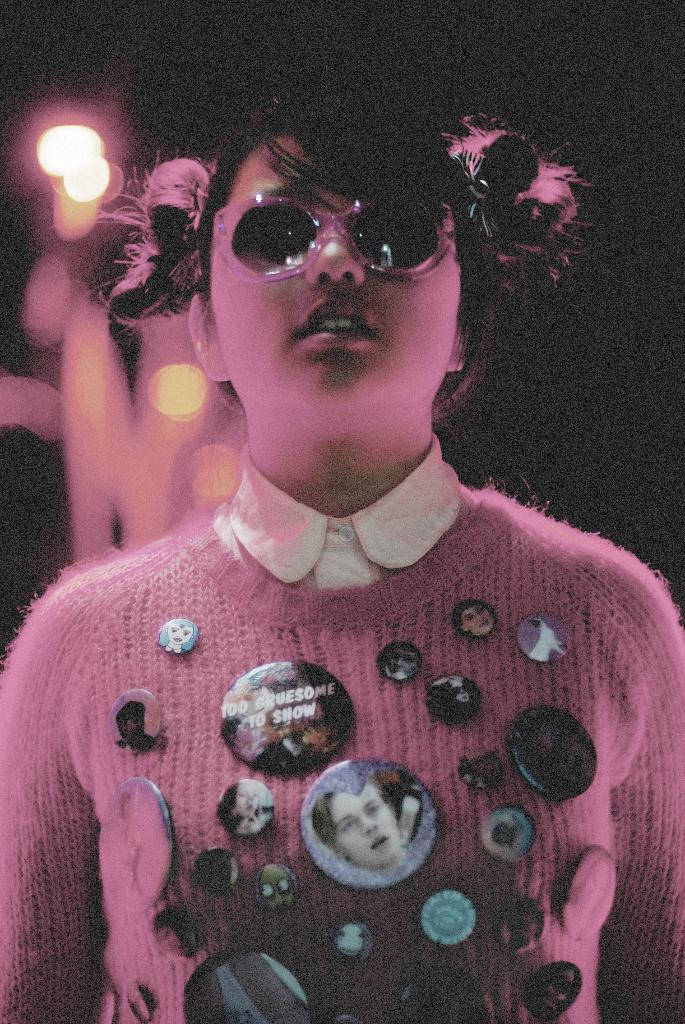Who is the main subject in the image? There is a woman in the image. What is the woman wearing on her face? The woman is wearing goggles. What type of accessories can be seen on the woman's clothes? The woman has badges attached to her clothes. Can you describe the background of the image? The background of the image appears blurry. What color is the kettle in the image? There is no kettle present in the image. Can you describe the woman's nose in the image? The woman's nose is not mentioned in the provided facts, so we cannot describe it. 